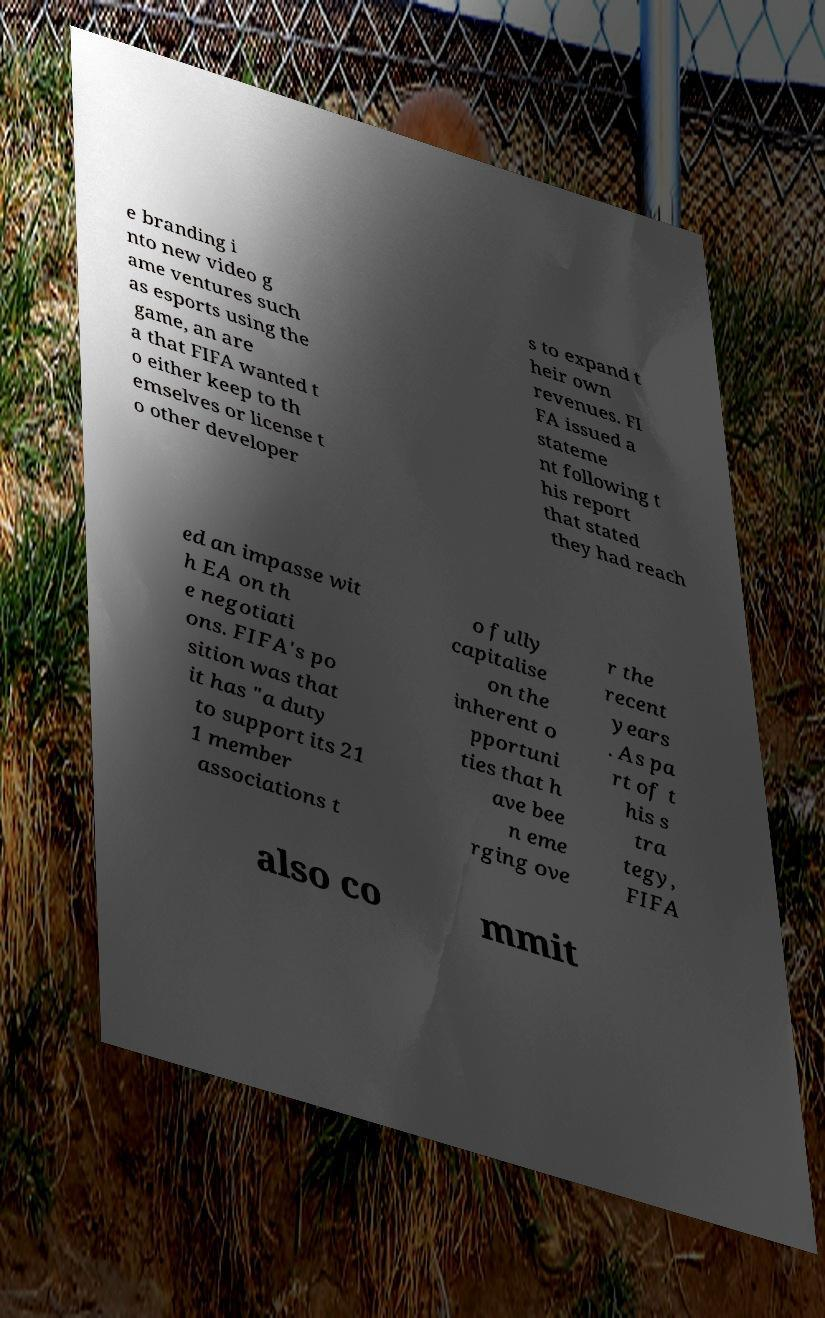I need the written content from this picture converted into text. Can you do that? e branding i nto new video g ame ventures such as esports using the game, an are a that FIFA wanted t o either keep to th emselves or license t o other developer s to expand t heir own revenues. FI FA issued a stateme nt following t his report that stated they had reach ed an impasse wit h EA on th e negotiati ons. FIFA's po sition was that it has "a duty to support its 21 1 member associations t o fully capitalise on the inherent o pportuni ties that h ave bee n eme rging ove r the recent years . As pa rt of t his s tra tegy, FIFA also co mmit 